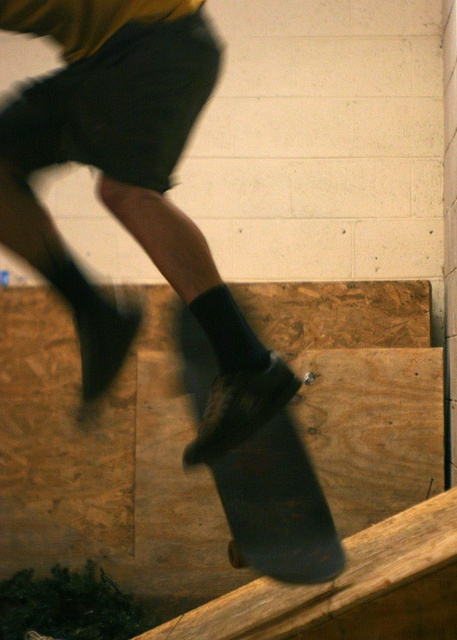Describe the objects in this image and their specific colors. I can see people in black, maroon, olive, and tan tones and skateboard in black and olive tones in this image. 